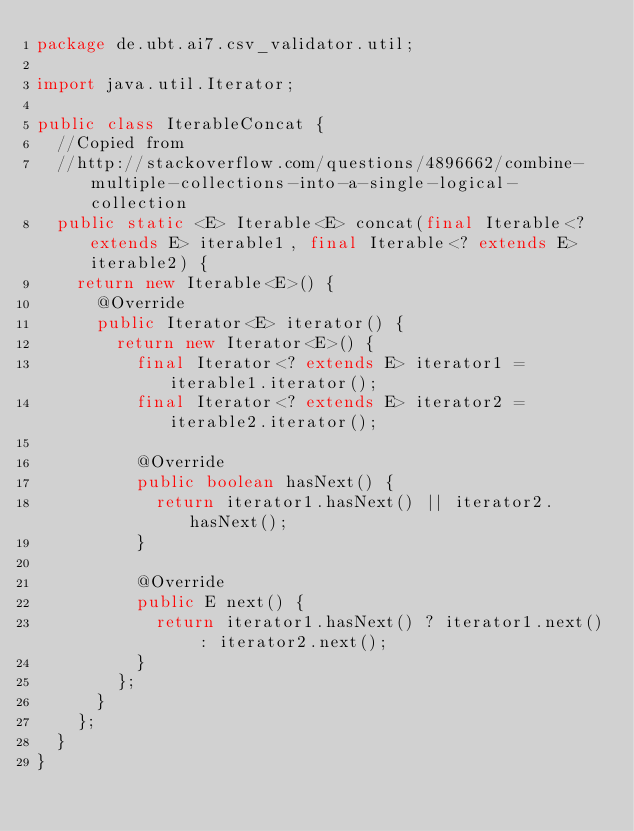Convert code to text. <code><loc_0><loc_0><loc_500><loc_500><_Java_>package de.ubt.ai7.csv_validator.util;

import java.util.Iterator;

public class IterableConcat {
	//Copied from 
	//http://stackoverflow.com/questions/4896662/combine-multiple-collections-into-a-single-logical-collection
	public static <E> Iterable<E> concat(final Iterable<? extends E> iterable1, final Iterable<? extends E> iterable2) {
		return new Iterable<E>() {
			@Override
			public Iterator<E> iterator() {
				return new Iterator<E>() {
					final Iterator<? extends E> iterator1 = iterable1.iterator();
					final Iterator<? extends E> iterator2 = iterable2.iterator();

					@Override
					public boolean hasNext() {
						return iterator1.hasNext() || iterator2.hasNext();
					}

					@Override
					public E next() {
						return iterator1.hasNext() ? iterator1.next() : iterator2.next();
					}
				};
			}
		};
	}
}
</code> 